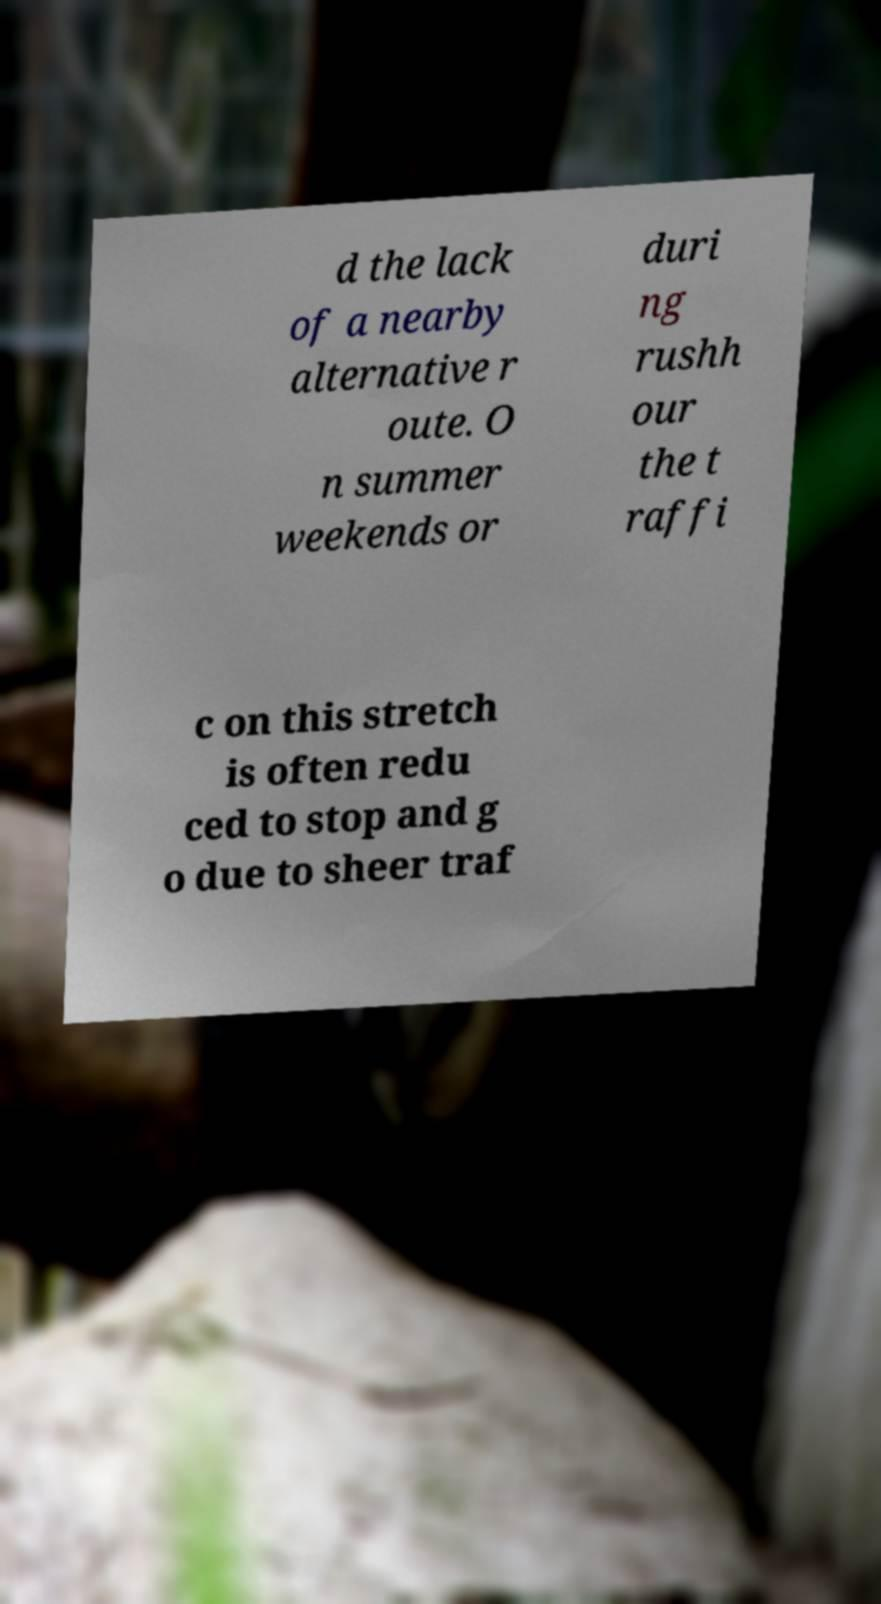I need the written content from this picture converted into text. Can you do that? d the lack of a nearby alternative r oute. O n summer weekends or duri ng rushh our the t raffi c on this stretch is often redu ced to stop and g o due to sheer traf 